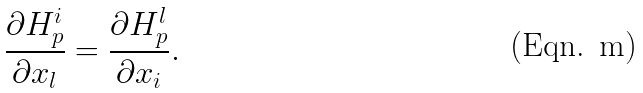Convert formula to latex. <formula><loc_0><loc_0><loc_500><loc_500>\frac { \partial H _ { p } ^ { i } } { \partial x _ { l } } = \frac { \partial H _ { p } ^ { l } } { \partial x _ { i } } .</formula> 